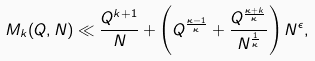<formula> <loc_0><loc_0><loc_500><loc_500>M _ { k } ( Q , N ) \ll \frac { Q ^ { k + 1 } } { N } + \left ( Q ^ { \frac { \kappa - 1 } { \kappa } } + \frac { Q ^ { \frac { \kappa + k } { \kappa } } } { N ^ { \frac { 1 } { \kappa } } } \right ) N ^ { \epsilon } ,</formula> 